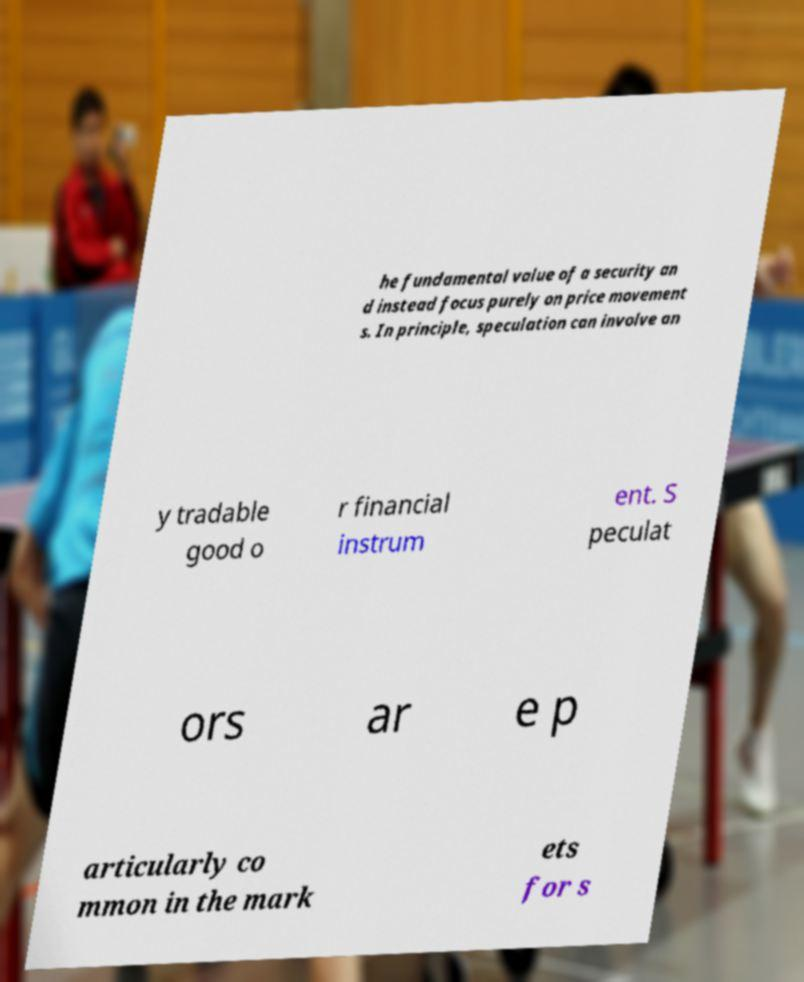I need the written content from this picture converted into text. Can you do that? he fundamental value of a security an d instead focus purely on price movement s. In principle, speculation can involve an y tradable good o r financial instrum ent. S peculat ors ar e p articularly co mmon in the mark ets for s 